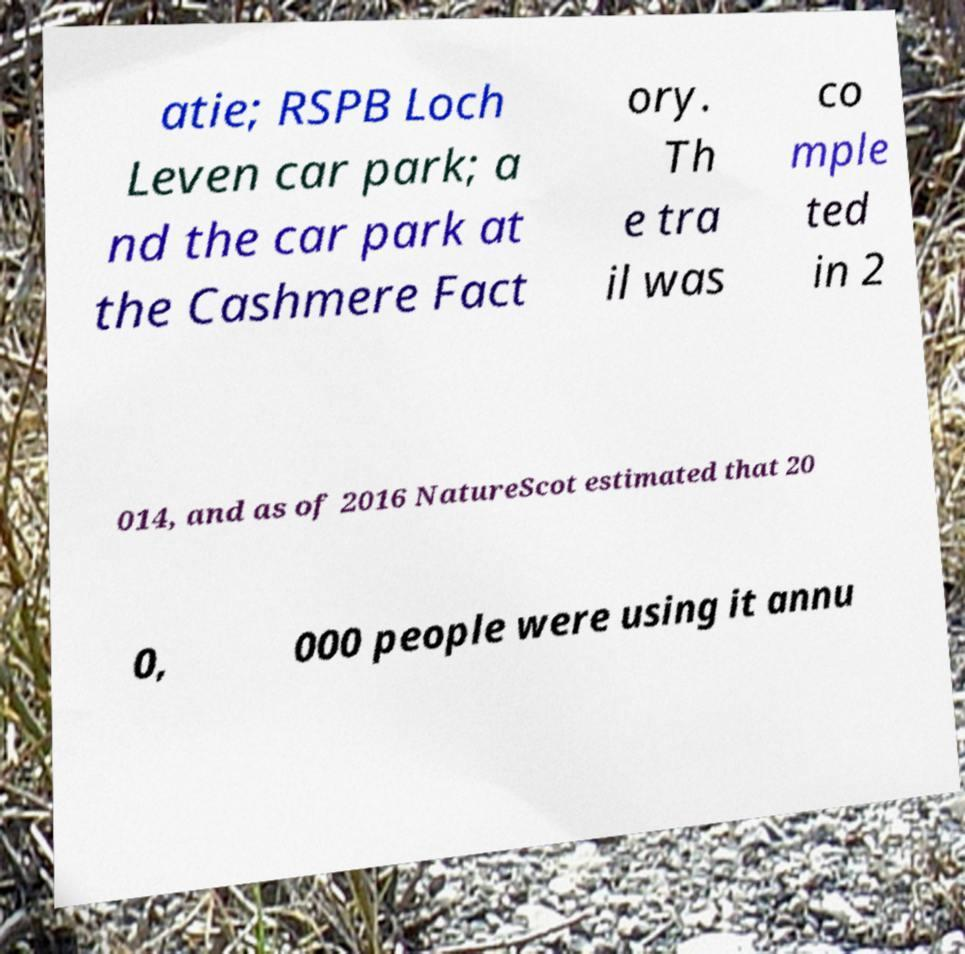Could you assist in decoding the text presented in this image and type it out clearly? atie; RSPB Loch Leven car park; a nd the car park at the Cashmere Fact ory. Th e tra il was co mple ted in 2 014, and as of 2016 NatureScot estimated that 20 0, 000 people were using it annu 